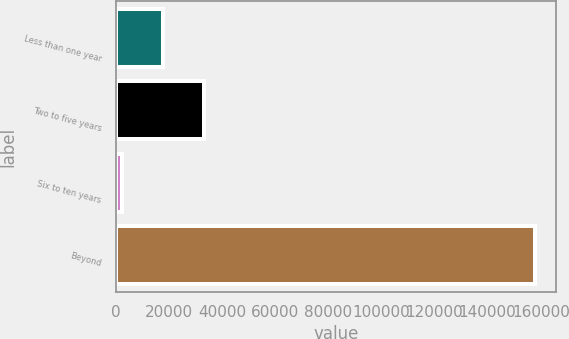Convert chart. <chart><loc_0><loc_0><loc_500><loc_500><bar_chart><fcel>Less than one year<fcel>Two to five years<fcel>Six to ten years<fcel>Beyond<nl><fcel>17777<fcel>33354<fcel>2200<fcel>157970<nl></chart> 